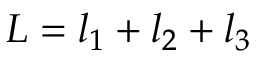<formula> <loc_0><loc_0><loc_500><loc_500>L = l _ { 1 } + l _ { 2 } + l _ { 3 }</formula> 